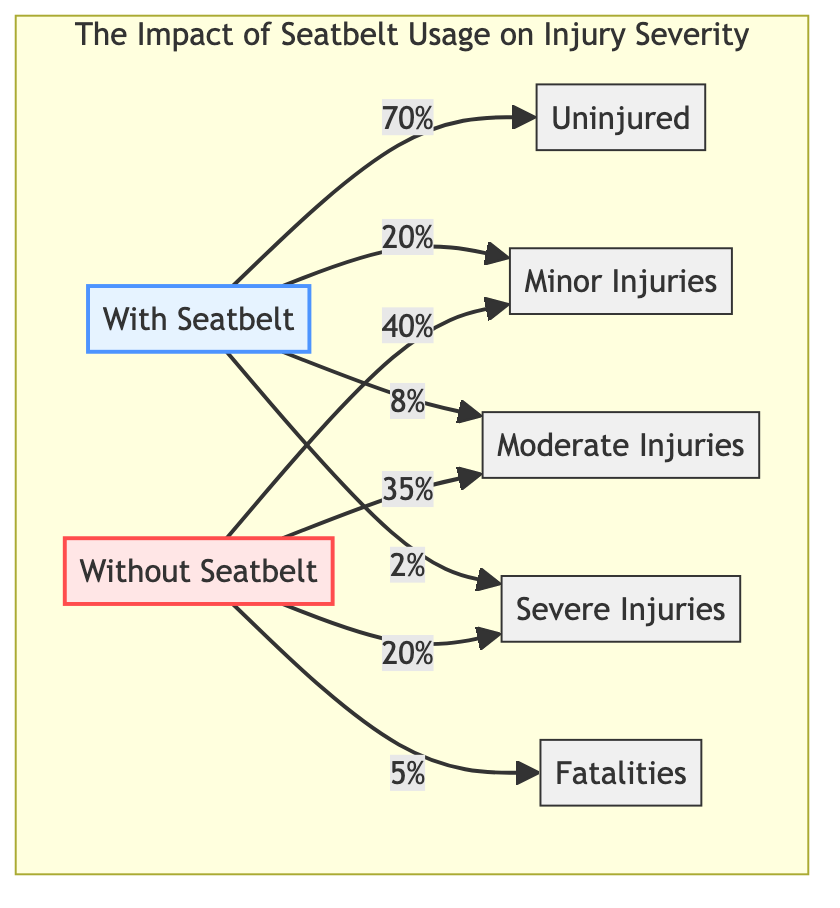What's the percentage of uninjured individuals with seatbelts? The diagram shows that 70% of individuals with seatbelts fall into the "Uninjured" category. This information can be found directly under the node representing "With Seatbelt."
Answer: 70% What percentage of individuals without seatbelts suffer severe injuries? For individuals without seatbelts, the diagram indicates that 20% sustain severe injuries. This value is located under the "Without Seatbelt" node.
Answer: 20% How many categories of injury severity are represented in the diagram? The diagram represents five categories of injury severity: Uninjured, Minor Injuries, Moderate Injuries, Severe Injuries, and Fatalities. This can be counted by reviewing the injury nodes in the diagram.
Answer: 5 What is the total percentage of fatalities without seatbelts? The diagram shows that 5% of individuals without seatbelts result in fatalities. The "Fatalities" node under the "Without Seatbelt" group indicates this percentage.
Answer: 5% Which group has a higher percentage of minor injuries, with or without seatbelts? The diagram indicates that 40% of individuals without seatbelts suffer from minor injuries, while only 20% of those with seatbelts do. Comparing the two values, it is clear that the "Without Seatbelt" group has a higher percentage.
Answer: Without Seatbelt What percentage of individuals with seatbelts experience moderate injuries? The diagram shows that 8% of individuals with seatbelts fall into the "Moderate Injuries" category. This percentage can be found directly under the "With Seatbelt" node.
Answer: 8% Which group shows a higher total percentage of severe outcomes (severe injuries and fatalities)? To determine this, we look at the severe outcomes for both groups. Individuals without seatbelts show 20% severe injuries and 5% fatalities, summing up to 25%. In contrast, those with seatbelts show only 2% severe injuries. Since 25% (without seatbelts) is higher than 2% (with seatbelts), the "Without Seatbelt" group has a higher total percentage of severe outcomes.
Answer: Without Seatbelt What is the combined percentage of minor and moderate injuries for individuals without seatbelts? The percentage of minor injuries is 35% and for moderate injuries, it is 40% for individuals without seatbelts. Adding these two values together gives a total of 75%. This can be calculated by summing both percentages shown under the "Without Seatbelt" node.
Answer: 75% 